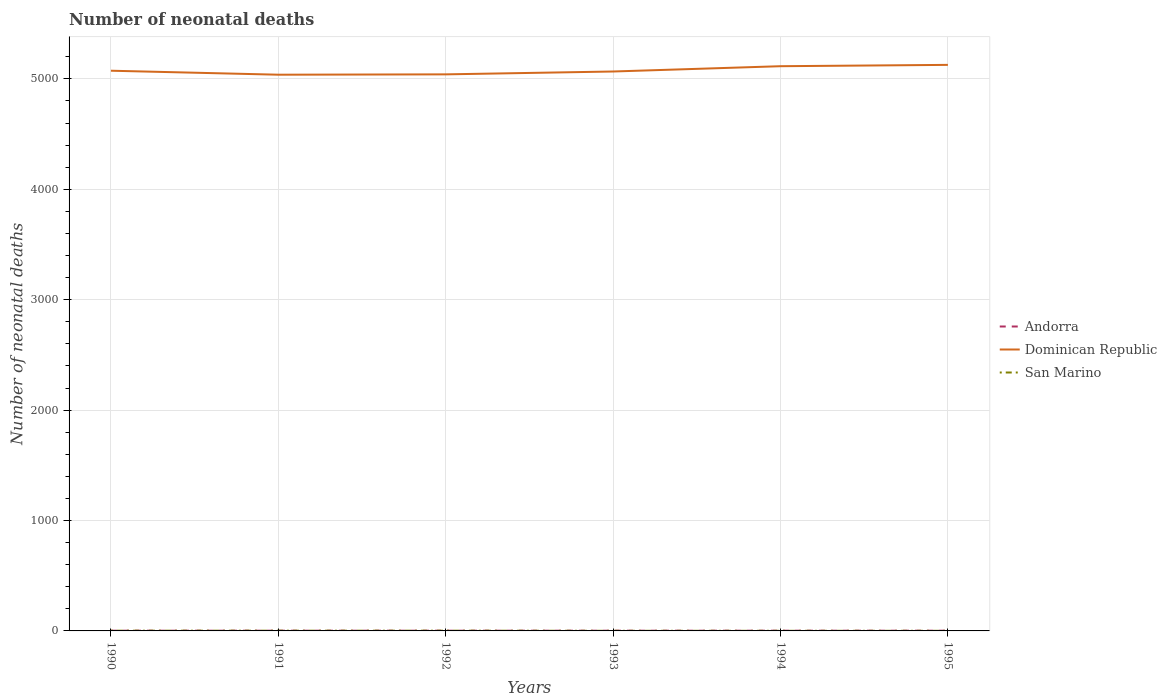How many different coloured lines are there?
Your response must be concise. 3. Does the line corresponding to San Marino intersect with the line corresponding to Andorra?
Make the answer very short. Yes. Across all years, what is the maximum number of neonatal deaths in in San Marino?
Your response must be concise. 1. What is the difference between the highest and the second highest number of neonatal deaths in in Dominican Republic?
Offer a very short reply. 89. How many lines are there?
Provide a succinct answer. 3. How many years are there in the graph?
Offer a terse response. 6. What is the difference between two consecutive major ticks on the Y-axis?
Give a very brief answer. 1000. Are the values on the major ticks of Y-axis written in scientific E-notation?
Keep it short and to the point. No. Does the graph contain any zero values?
Keep it short and to the point. No. Does the graph contain grids?
Provide a short and direct response. Yes. Where does the legend appear in the graph?
Offer a very short reply. Center right. How many legend labels are there?
Your response must be concise. 3. What is the title of the graph?
Offer a terse response. Number of neonatal deaths. What is the label or title of the Y-axis?
Provide a short and direct response. Number of neonatal deaths. What is the Number of neonatal deaths of Dominican Republic in 1990?
Keep it short and to the point. 5074. What is the Number of neonatal deaths of San Marino in 1990?
Provide a succinct answer. 2. What is the Number of neonatal deaths of Dominican Republic in 1991?
Give a very brief answer. 5038. What is the Number of neonatal deaths of San Marino in 1991?
Keep it short and to the point. 2. What is the Number of neonatal deaths in Andorra in 1992?
Provide a succinct answer. 2. What is the Number of neonatal deaths in Dominican Republic in 1992?
Your answer should be compact. 5041. What is the Number of neonatal deaths of San Marino in 1992?
Your answer should be very brief. 2. What is the Number of neonatal deaths in Andorra in 1993?
Offer a very short reply. 2. What is the Number of neonatal deaths of Dominican Republic in 1993?
Offer a very short reply. 5067. What is the Number of neonatal deaths of Andorra in 1994?
Offer a terse response. 2. What is the Number of neonatal deaths of Dominican Republic in 1994?
Your response must be concise. 5115. What is the Number of neonatal deaths in Dominican Republic in 1995?
Your answer should be very brief. 5127. Across all years, what is the maximum Number of neonatal deaths of Andorra?
Ensure brevity in your answer.  2. Across all years, what is the maximum Number of neonatal deaths of Dominican Republic?
Make the answer very short. 5127. Across all years, what is the maximum Number of neonatal deaths of San Marino?
Your response must be concise. 2. Across all years, what is the minimum Number of neonatal deaths of Dominican Republic?
Give a very brief answer. 5038. Across all years, what is the minimum Number of neonatal deaths of San Marino?
Your response must be concise. 1. What is the total Number of neonatal deaths in Dominican Republic in the graph?
Keep it short and to the point. 3.05e+04. What is the difference between the Number of neonatal deaths in Dominican Republic in 1990 and that in 1991?
Ensure brevity in your answer.  36. What is the difference between the Number of neonatal deaths of San Marino in 1990 and that in 1992?
Keep it short and to the point. 0. What is the difference between the Number of neonatal deaths in Andorra in 1990 and that in 1994?
Keep it short and to the point. 0. What is the difference between the Number of neonatal deaths in Dominican Republic in 1990 and that in 1994?
Your response must be concise. -41. What is the difference between the Number of neonatal deaths of San Marino in 1990 and that in 1994?
Provide a short and direct response. 1. What is the difference between the Number of neonatal deaths in Dominican Republic in 1990 and that in 1995?
Your answer should be compact. -53. What is the difference between the Number of neonatal deaths in San Marino in 1990 and that in 1995?
Your answer should be compact. 1. What is the difference between the Number of neonatal deaths of San Marino in 1991 and that in 1992?
Your response must be concise. 0. What is the difference between the Number of neonatal deaths in Andorra in 1991 and that in 1993?
Give a very brief answer. 0. What is the difference between the Number of neonatal deaths of Dominican Republic in 1991 and that in 1993?
Offer a terse response. -29. What is the difference between the Number of neonatal deaths of San Marino in 1991 and that in 1993?
Offer a very short reply. 1. What is the difference between the Number of neonatal deaths in Dominican Republic in 1991 and that in 1994?
Your answer should be compact. -77. What is the difference between the Number of neonatal deaths of Andorra in 1991 and that in 1995?
Your answer should be compact. 0. What is the difference between the Number of neonatal deaths in Dominican Republic in 1991 and that in 1995?
Provide a succinct answer. -89. What is the difference between the Number of neonatal deaths of San Marino in 1991 and that in 1995?
Offer a very short reply. 1. What is the difference between the Number of neonatal deaths in San Marino in 1992 and that in 1993?
Offer a very short reply. 1. What is the difference between the Number of neonatal deaths of Dominican Republic in 1992 and that in 1994?
Give a very brief answer. -74. What is the difference between the Number of neonatal deaths of San Marino in 1992 and that in 1994?
Give a very brief answer. 1. What is the difference between the Number of neonatal deaths of Dominican Republic in 1992 and that in 1995?
Ensure brevity in your answer.  -86. What is the difference between the Number of neonatal deaths of Andorra in 1993 and that in 1994?
Give a very brief answer. 0. What is the difference between the Number of neonatal deaths of Dominican Republic in 1993 and that in 1994?
Offer a very short reply. -48. What is the difference between the Number of neonatal deaths in San Marino in 1993 and that in 1994?
Offer a terse response. 0. What is the difference between the Number of neonatal deaths of Andorra in 1993 and that in 1995?
Make the answer very short. 0. What is the difference between the Number of neonatal deaths in Dominican Republic in 1993 and that in 1995?
Keep it short and to the point. -60. What is the difference between the Number of neonatal deaths of San Marino in 1993 and that in 1995?
Your answer should be compact. 0. What is the difference between the Number of neonatal deaths of Andorra in 1994 and that in 1995?
Provide a succinct answer. 0. What is the difference between the Number of neonatal deaths in Dominican Republic in 1994 and that in 1995?
Make the answer very short. -12. What is the difference between the Number of neonatal deaths in San Marino in 1994 and that in 1995?
Your response must be concise. 0. What is the difference between the Number of neonatal deaths in Andorra in 1990 and the Number of neonatal deaths in Dominican Republic in 1991?
Provide a short and direct response. -5036. What is the difference between the Number of neonatal deaths of Andorra in 1990 and the Number of neonatal deaths of San Marino in 1991?
Your answer should be compact. 0. What is the difference between the Number of neonatal deaths of Dominican Republic in 1990 and the Number of neonatal deaths of San Marino in 1991?
Offer a very short reply. 5072. What is the difference between the Number of neonatal deaths of Andorra in 1990 and the Number of neonatal deaths of Dominican Republic in 1992?
Offer a very short reply. -5039. What is the difference between the Number of neonatal deaths in Dominican Republic in 1990 and the Number of neonatal deaths in San Marino in 1992?
Offer a very short reply. 5072. What is the difference between the Number of neonatal deaths of Andorra in 1990 and the Number of neonatal deaths of Dominican Republic in 1993?
Make the answer very short. -5065. What is the difference between the Number of neonatal deaths in Andorra in 1990 and the Number of neonatal deaths in San Marino in 1993?
Your answer should be compact. 1. What is the difference between the Number of neonatal deaths of Dominican Republic in 1990 and the Number of neonatal deaths of San Marino in 1993?
Provide a short and direct response. 5073. What is the difference between the Number of neonatal deaths of Andorra in 1990 and the Number of neonatal deaths of Dominican Republic in 1994?
Your answer should be very brief. -5113. What is the difference between the Number of neonatal deaths in Dominican Republic in 1990 and the Number of neonatal deaths in San Marino in 1994?
Your answer should be very brief. 5073. What is the difference between the Number of neonatal deaths of Andorra in 1990 and the Number of neonatal deaths of Dominican Republic in 1995?
Ensure brevity in your answer.  -5125. What is the difference between the Number of neonatal deaths in Dominican Republic in 1990 and the Number of neonatal deaths in San Marino in 1995?
Offer a terse response. 5073. What is the difference between the Number of neonatal deaths of Andorra in 1991 and the Number of neonatal deaths of Dominican Republic in 1992?
Make the answer very short. -5039. What is the difference between the Number of neonatal deaths of Andorra in 1991 and the Number of neonatal deaths of San Marino in 1992?
Your answer should be very brief. 0. What is the difference between the Number of neonatal deaths in Dominican Republic in 1991 and the Number of neonatal deaths in San Marino in 1992?
Provide a short and direct response. 5036. What is the difference between the Number of neonatal deaths in Andorra in 1991 and the Number of neonatal deaths in Dominican Republic in 1993?
Your response must be concise. -5065. What is the difference between the Number of neonatal deaths in Dominican Republic in 1991 and the Number of neonatal deaths in San Marino in 1993?
Your answer should be very brief. 5037. What is the difference between the Number of neonatal deaths in Andorra in 1991 and the Number of neonatal deaths in Dominican Republic in 1994?
Give a very brief answer. -5113. What is the difference between the Number of neonatal deaths of Dominican Republic in 1991 and the Number of neonatal deaths of San Marino in 1994?
Your answer should be very brief. 5037. What is the difference between the Number of neonatal deaths of Andorra in 1991 and the Number of neonatal deaths of Dominican Republic in 1995?
Your answer should be compact. -5125. What is the difference between the Number of neonatal deaths of Andorra in 1991 and the Number of neonatal deaths of San Marino in 1995?
Ensure brevity in your answer.  1. What is the difference between the Number of neonatal deaths in Dominican Republic in 1991 and the Number of neonatal deaths in San Marino in 1995?
Offer a very short reply. 5037. What is the difference between the Number of neonatal deaths in Andorra in 1992 and the Number of neonatal deaths in Dominican Republic in 1993?
Your answer should be very brief. -5065. What is the difference between the Number of neonatal deaths of Dominican Republic in 1992 and the Number of neonatal deaths of San Marino in 1993?
Make the answer very short. 5040. What is the difference between the Number of neonatal deaths of Andorra in 1992 and the Number of neonatal deaths of Dominican Republic in 1994?
Ensure brevity in your answer.  -5113. What is the difference between the Number of neonatal deaths in Dominican Republic in 1992 and the Number of neonatal deaths in San Marino in 1994?
Give a very brief answer. 5040. What is the difference between the Number of neonatal deaths of Andorra in 1992 and the Number of neonatal deaths of Dominican Republic in 1995?
Your answer should be very brief. -5125. What is the difference between the Number of neonatal deaths in Dominican Republic in 1992 and the Number of neonatal deaths in San Marino in 1995?
Your answer should be compact. 5040. What is the difference between the Number of neonatal deaths in Andorra in 1993 and the Number of neonatal deaths in Dominican Republic in 1994?
Give a very brief answer. -5113. What is the difference between the Number of neonatal deaths in Dominican Republic in 1993 and the Number of neonatal deaths in San Marino in 1994?
Ensure brevity in your answer.  5066. What is the difference between the Number of neonatal deaths of Andorra in 1993 and the Number of neonatal deaths of Dominican Republic in 1995?
Your answer should be compact. -5125. What is the difference between the Number of neonatal deaths of Andorra in 1993 and the Number of neonatal deaths of San Marino in 1995?
Ensure brevity in your answer.  1. What is the difference between the Number of neonatal deaths of Dominican Republic in 1993 and the Number of neonatal deaths of San Marino in 1995?
Your response must be concise. 5066. What is the difference between the Number of neonatal deaths of Andorra in 1994 and the Number of neonatal deaths of Dominican Republic in 1995?
Keep it short and to the point. -5125. What is the difference between the Number of neonatal deaths of Andorra in 1994 and the Number of neonatal deaths of San Marino in 1995?
Your response must be concise. 1. What is the difference between the Number of neonatal deaths of Dominican Republic in 1994 and the Number of neonatal deaths of San Marino in 1995?
Your response must be concise. 5114. What is the average Number of neonatal deaths of Andorra per year?
Offer a very short reply. 2. What is the average Number of neonatal deaths of Dominican Republic per year?
Offer a very short reply. 5077. In the year 1990, what is the difference between the Number of neonatal deaths in Andorra and Number of neonatal deaths in Dominican Republic?
Offer a terse response. -5072. In the year 1990, what is the difference between the Number of neonatal deaths of Andorra and Number of neonatal deaths of San Marino?
Your response must be concise. 0. In the year 1990, what is the difference between the Number of neonatal deaths in Dominican Republic and Number of neonatal deaths in San Marino?
Your answer should be compact. 5072. In the year 1991, what is the difference between the Number of neonatal deaths in Andorra and Number of neonatal deaths in Dominican Republic?
Make the answer very short. -5036. In the year 1991, what is the difference between the Number of neonatal deaths in Andorra and Number of neonatal deaths in San Marino?
Your answer should be very brief. 0. In the year 1991, what is the difference between the Number of neonatal deaths in Dominican Republic and Number of neonatal deaths in San Marino?
Your answer should be very brief. 5036. In the year 1992, what is the difference between the Number of neonatal deaths in Andorra and Number of neonatal deaths in Dominican Republic?
Make the answer very short. -5039. In the year 1992, what is the difference between the Number of neonatal deaths of Dominican Republic and Number of neonatal deaths of San Marino?
Keep it short and to the point. 5039. In the year 1993, what is the difference between the Number of neonatal deaths in Andorra and Number of neonatal deaths in Dominican Republic?
Make the answer very short. -5065. In the year 1993, what is the difference between the Number of neonatal deaths in Andorra and Number of neonatal deaths in San Marino?
Offer a terse response. 1. In the year 1993, what is the difference between the Number of neonatal deaths of Dominican Republic and Number of neonatal deaths of San Marino?
Make the answer very short. 5066. In the year 1994, what is the difference between the Number of neonatal deaths of Andorra and Number of neonatal deaths of Dominican Republic?
Your response must be concise. -5113. In the year 1994, what is the difference between the Number of neonatal deaths of Andorra and Number of neonatal deaths of San Marino?
Give a very brief answer. 1. In the year 1994, what is the difference between the Number of neonatal deaths of Dominican Republic and Number of neonatal deaths of San Marino?
Provide a succinct answer. 5114. In the year 1995, what is the difference between the Number of neonatal deaths of Andorra and Number of neonatal deaths of Dominican Republic?
Make the answer very short. -5125. In the year 1995, what is the difference between the Number of neonatal deaths of Dominican Republic and Number of neonatal deaths of San Marino?
Your answer should be compact. 5126. What is the ratio of the Number of neonatal deaths in Andorra in 1990 to that in 1991?
Give a very brief answer. 1. What is the ratio of the Number of neonatal deaths in Dominican Republic in 1990 to that in 1991?
Your answer should be very brief. 1.01. What is the ratio of the Number of neonatal deaths in San Marino in 1990 to that in 1991?
Ensure brevity in your answer.  1. What is the ratio of the Number of neonatal deaths of Andorra in 1990 to that in 1992?
Provide a succinct answer. 1. What is the ratio of the Number of neonatal deaths of San Marino in 1990 to that in 1993?
Your answer should be very brief. 2. What is the ratio of the Number of neonatal deaths of Dominican Republic in 1990 to that in 1994?
Provide a succinct answer. 0.99. What is the ratio of the Number of neonatal deaths in San Marino in 1990 to that in 1995?
Your answer should be compact. 2. What is the ratio of the Number of neonatal deaths of Andorra in 1991 to that in 1992?
Offer a very short reply. 1. What is the ratio of the Number of neonatal deaths in San Marino in 1991 to that in 1992?
Offer a terse response. 1. What is the ratio of the Number of neonatal deaths in Andorra in 1991 to that in 1993?
Offer a terse response. 1. What is the ratio of the Number of neonatal deaths in Dominican Republic in 1991 to that in 1993?
Your answer should be very brief. 0.99. What is the ratio of the Number of neonatal deaths in San Marino in 1991 to that in 1993?
Your answer should be very brief. 2. What is the ratio of the Number of neonatal deaths in Andorra in 1991 to that in 1994?
Ensure brevity in your answer.  1. What is the ratio of the Number of neonatal deaths in Dominican Republic in 1991 to that in 1994?
Make the answer very short. 0.98. What is the ratio of the Number of neonatal deaths in San Marino in 1991 to that in 1994?
Your response must be concise. 2. What is the ratio of the Number of neonatal deaths of Andorra in 1991 to that in 1995?
Ensure brevity in your answer.  1. What is the ratio of the Number of neonatal deaths of Dominican Republic in 1991 to that in 1995?
Your response must be concise. 0.98. What is the ratio of the Number of neonatal deaths in Dominican Republic in 1992 to that in 1993?
Your response must be concise. 0.99. What is the ratio of the Number of neonatal deaths of San Marino in 1992 to that in 1993?
Offer a very short reply. 2. What is the ratio of the Number of neonatal deaths in Dominican Republic in 1992 to that in 1994?
Give a very brief answer. 0.99. What is the ratio of the Number of neonatal deaths in Andorra in 1992 to that in 1995?
Your answer should be compact. 1. What is the ratio of the Number of neonatal deaths of Dominican Republic in 1992 to that in 1995?
Provide a short and direct response. 0.98. What is the ratio of the Number of neonatal deaths of San Marino in 1992 to that in 1995?
Offer a very short reply. 2. What is the ratio of the Number of neonatal deaths of Andorra in 1993 to that in 1994?
Make the answer very short. 1. What is the ratio of the Number of neonatal deaths of Dominican Republic in 1993 to that in 1994?
Your answer should be very brief. 0.99. What is the ratio of the Number of neonatal deaths of Dominican Republic in 1993 to that in 1995?
Give a very brief answer. 0.99. What is the ratio of the Number of neonatal deaths in San Marino in 1993 to that in 1995?
Give a very brief answer. 1. What is the difference between the highest and the lowest Number of neonatal deaths in Andorra?
Give a very brief answer. 0. What is the difference between the highest and the lowest Number of neonatal deaths in Dominican Republic?
Ensure brevity in your answer.  89. 